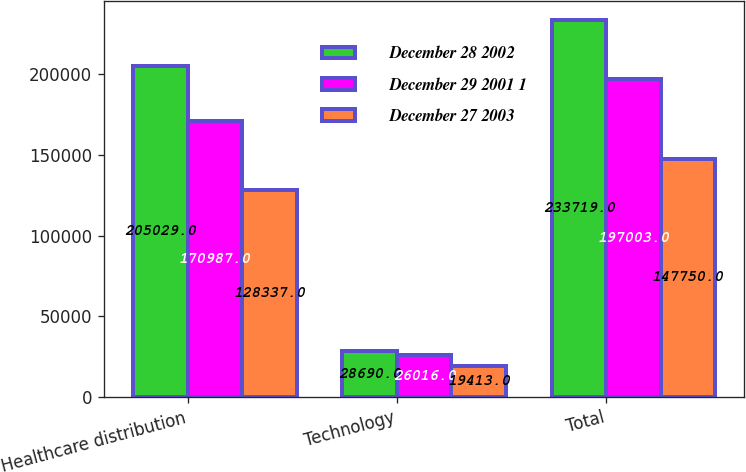Convert chart. <chart><loc_0><loc_0><loc_500><loc_500><stacked_bar_chart><ecel><fcel>Healthcare distribution<fcel>Technology<fcel>Total<nl><fcel>December 28 2002<fcel>205029<fcel>28690<fcel>233719<nl><fcel>December 29 2001 1<fcel>170987<fcel>26016<fcel>197003<nl><fcel>December 27 2003<fcel>128337<fcel>19413<fcel>147750<nl></chart> 